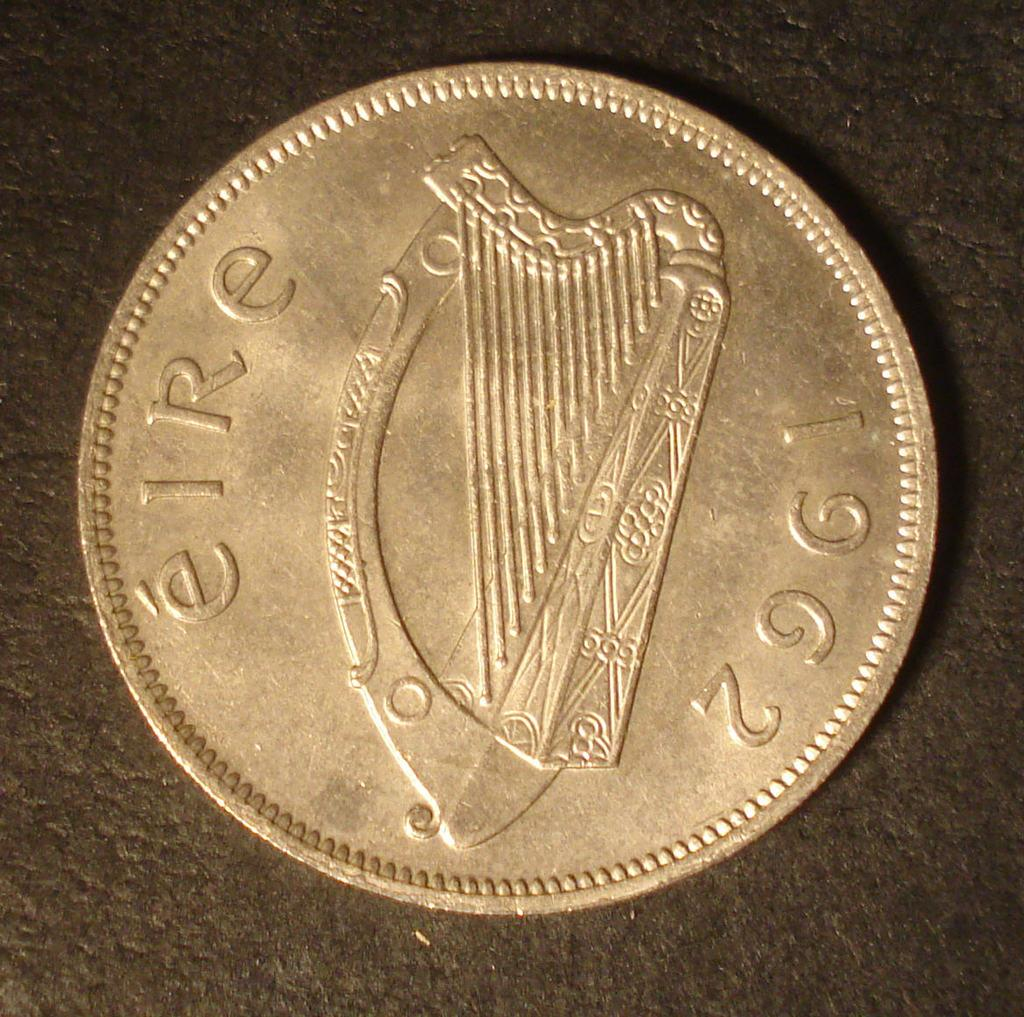<image>
Write a terse but informative summary of the picture. A 1962 gold colored coin that features a stringed instrument. 